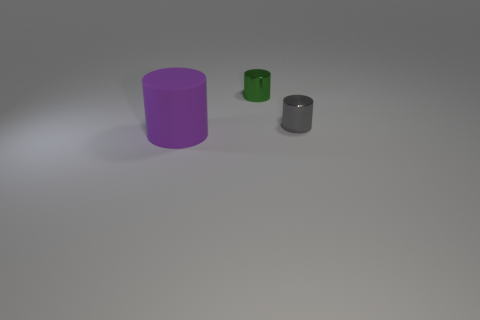Is there anything else that is the same size as the matte cylinder?
Your answer should be compact. No. Is there anything else that has the same material as the big purple cylinder?
Your response must be concise. No. How many other shiny things are the same shape as the green thing?
Give a very brief answer. 1. There is a object that is in front of the tiny gray metal cylinder; does it have the same size as the shiny object right of the small green metal object?
Ensure brevity in your answer.  No. There is a tiny thing to the right of the tiny green shiny cylinder; what shape is it?
Provide a short and direct response. Cylinder. There is another small thing that is the same shape as the tiny green thing; what is its material?
Offer a terse response. Metal. Is the size of the thing on the left side of the green thing the same as the gray cylinder?
Offer a very short reply. No. There is a purple rubber object; how many large purple rubber objects are in front of it?
Your answer should be compact. 0. Is the number of purple cylinders that are right of the small gray metallic cylinder less than the number of gray cylinders behind the green object?
Your answer should be compact. No. How many red metallic cylinders are there?
Ensure brevity in your answer.  0. 